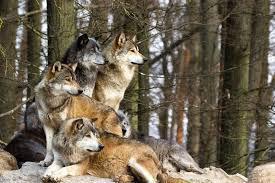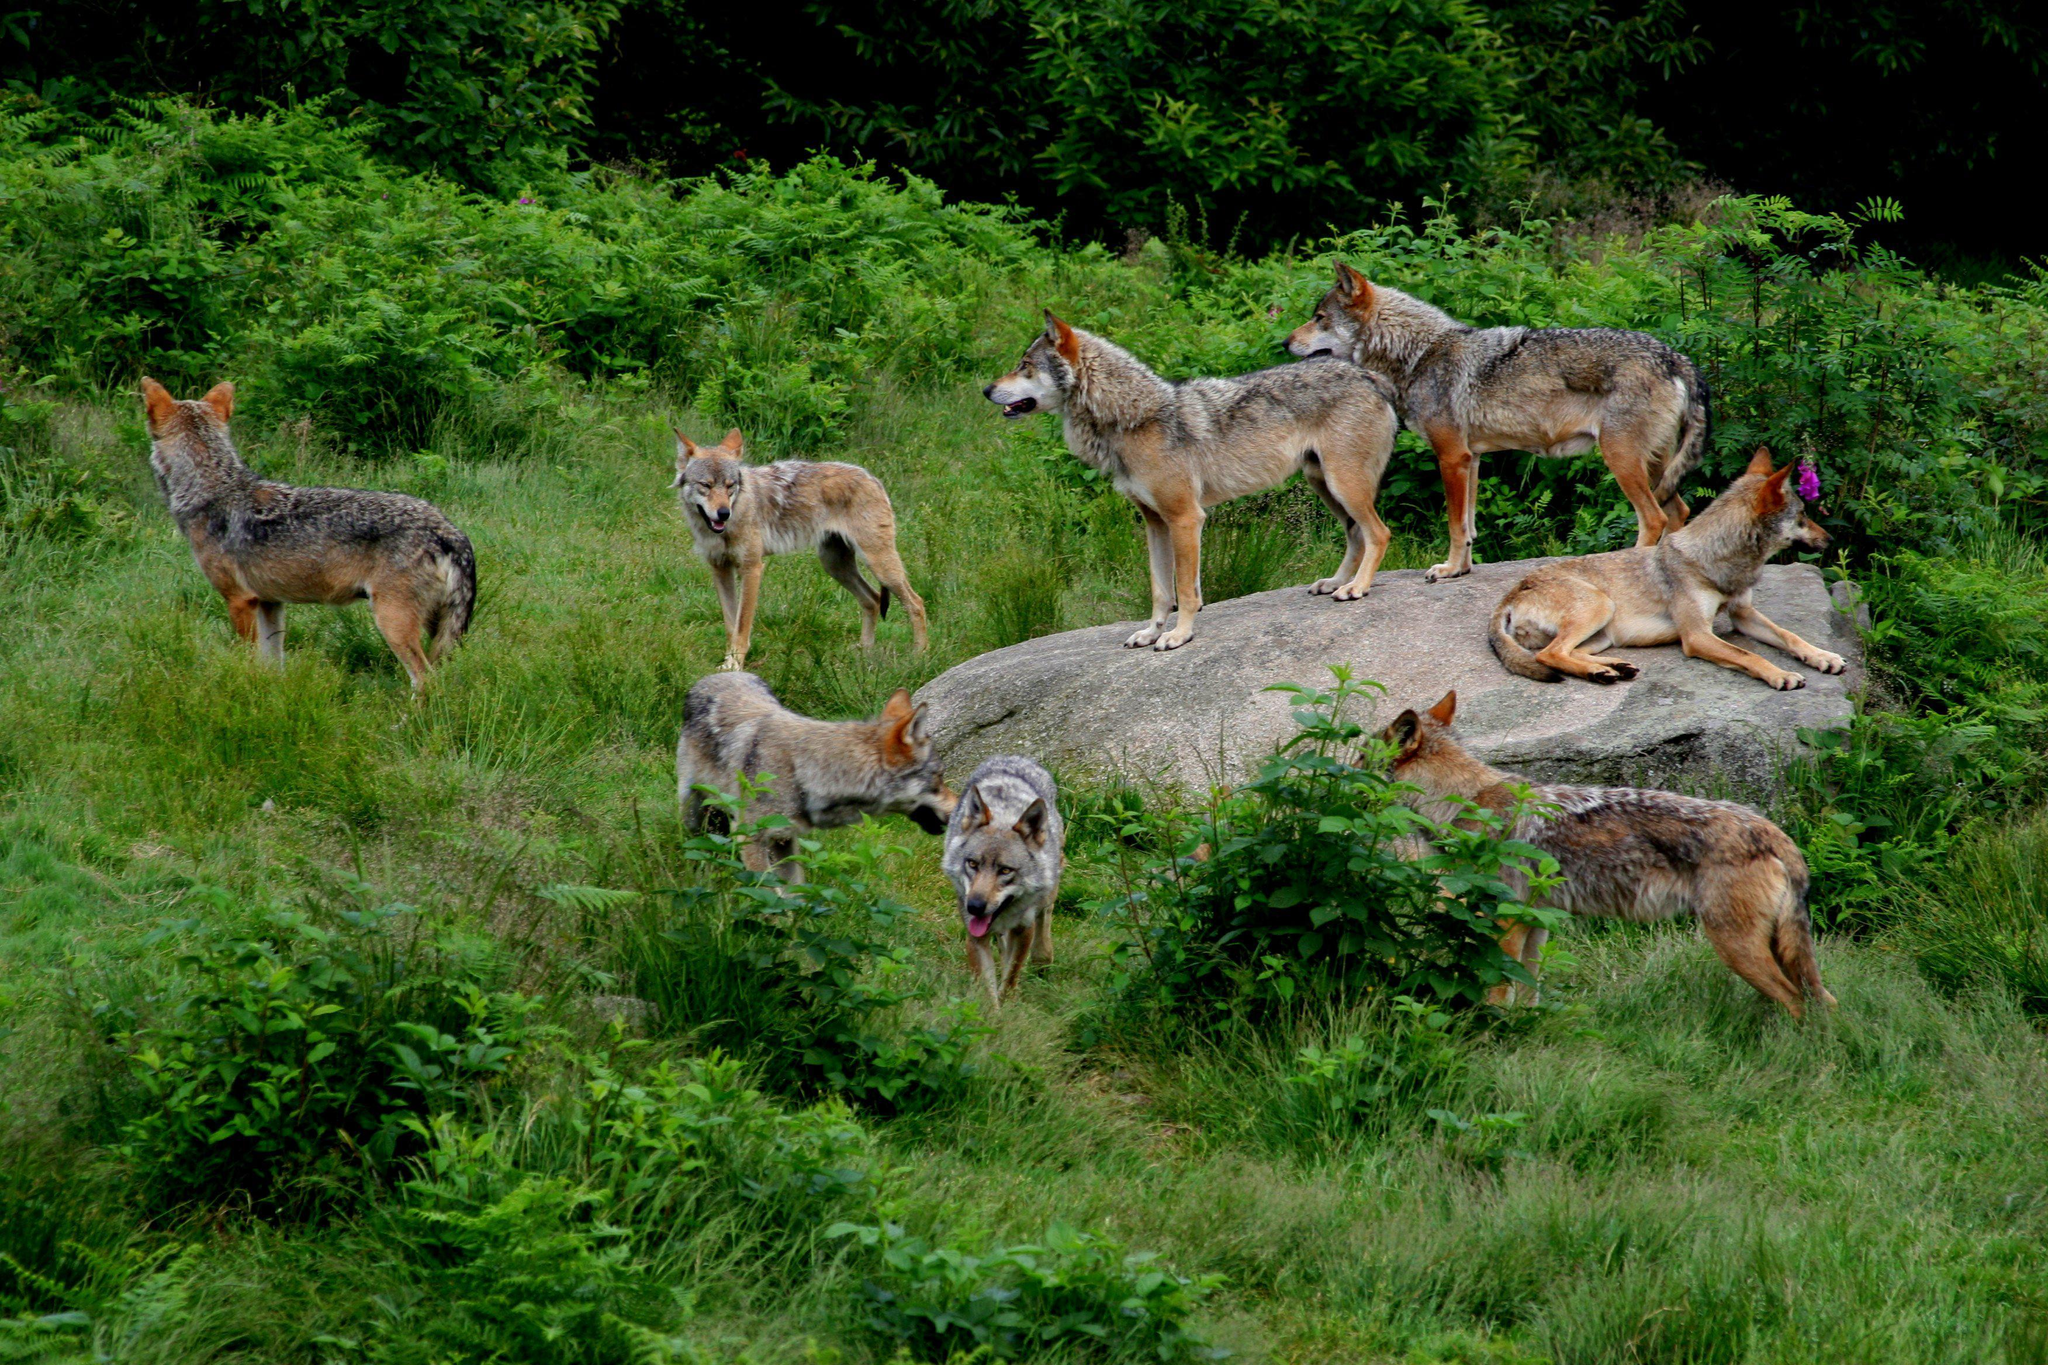The first image is the image on the left, the second image is the image on the right. Analyze the images presented: Is the assertion "The right image contains no more than one wolf." valid? Answer yes or no. No. The first image is the image on the left, the second image is the image on the right. Considering the images on both sides, is "There are five wolves in total." valid? Answer yes or no. No. 